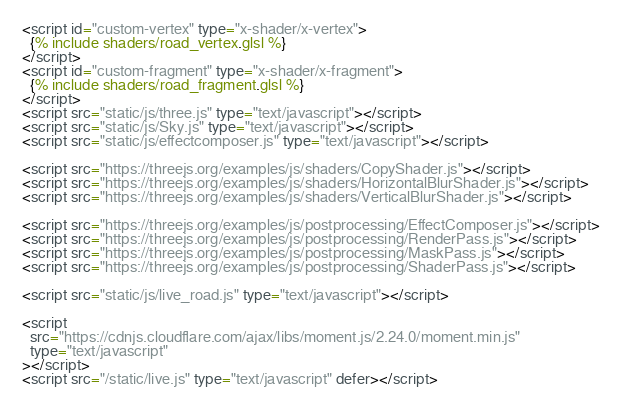Convert code to text. <code><loc_0><loc_0><loc_500><loc_500><_HTML_><script id="custom-vertex" type="x-shader/x-vertex">
  {% include shaders/road_vertex.glsl %}
</script>
<script id="custom-fragment" type="x-shader/x-fragment">
  {% include shaders/road_fragment.glsl %}
</script>
<script src="static/js/three.js" type="text/javascript"></script>
<script src="static/js/Sky.js" type="text/javascript"></script>
<script src="static/js/effectcomposer.js" type="text/javascript"></script>

<script src="https://threejs.org/examples/js/shaders/CopyShader.js"></script>
<script src="https://threejs.org/examples/js/shaders/HorizontalBlurShader.js"></script>
<script src="https://threejs.org/examples/js/shaders/VerticalBlurShader.js"></script>

<script src="https://threejs.org/examples/js/postprocessing/EffectComposer.js"></script>
<script src="https://threejs.org/examples/js/postprocessing/RenderPass.js"></script>
<script src="https://threejs.org/examples/js/postprocessing/MaskPass.js"></script>
<script src="https://threejs.org/examples/js/postprocessing/ShaderPass.js"></script>

<script src="static/js/live_road.js" type="text/javascript"></script>

<script
  src="https://cdnjs.cloudflare.com/ajax/libs/moment.js/2.24.0/moment.min.js"
  type="text/javascript"
></script>
<script src="/static/live.js" type="text/javascript" defer></script>
</code> 